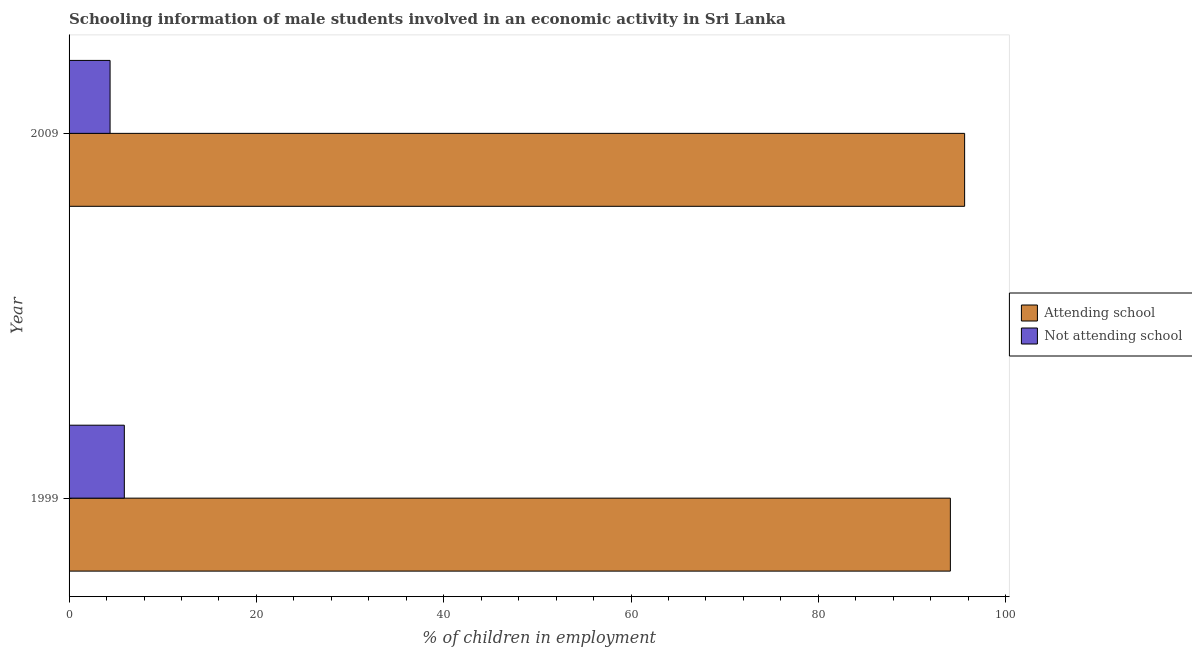How many different coloured bars are there?
Your response must be concise. 2. Are the number of bars on each tick of the Y-axis equal?
Offer a very short reply. Yes. How many bars are there on the 2nd tick from the top?
Offer a terse response. 2. How many bars are there on the 2nd tick from the bottom?
Your response must be concise. 2. What is the label of the 1st group of bars from the top?
Give a very brief answer. 2009. In how many cases, is the number of bars for a given year not equal to the number of legend labels?
Make the answer very short. 0. What is the percentage of employed males who are not attending school in 1999?
Offer a terse response. 5.9. Across all years, what is the maximum percentage of employed males who are attending school?
Offer a very short reply. 95.62. Across all years, what is the minimum percentage of employed males who are not attending school?
Keep it short and to the point. 4.38. In which year was the percentage of employed males who are not attending school maximum?
Your answer should be compact. 1999. In which year was the percentage of employed males who are attending school minimum?
Ensure brevity in your answer.  1999. What is the total percentage of employed males who are not attending school in the graph?
Your response must be concise. 10.28. What is the difference between the percentage of employed males who are attending school in 1999 and that in 2009?
Provide a short and direct response. -1.52. What is the difference between the percentage of employed males who are not attending school in 2009 and the percentage of employed males who are attending school in 1999?
Your response must be concise. -89.72. What is the average percentage of employed males who are not attending school per year?
Offer a terse response. 5.14. In the year 1999, what is the difference between the percentage of employed males who are not attending school and percentage of employed males who are attending school?
Your answer should be compact. -88.2. What is the ratio of the percentage of employed males who are not attending school in 1999 to that in 2009?
Make the answer very short. 1.35. Is the percentage of employed males who are attending school in 1999 less than that in 2009?
Make the answer very short. Yes. In how many years, is the percentage of employed males who are not attending school greater than the average percentage of employed males who are not attending school taken over all years?
Your answer should be compact. 1. What does the 1st bar from the top in 2009 represents?
Provide a succinct answer. Not attending school. What does the 2nd bar from the bottom in 2009 represents?
Provide a short and direct response. Not attending school. Are all the bars in the graph horizontal?
Give a very brief answer. Yes. What is the difference between two consecutive major ticks on the X-axis?
Ensure brevity in your answer.  20. How many legend labels are there?
Offer a very short reply. 2. How are the legend labels stacked?
Provide a succinct answer. Vertical. What is the title of the graph?
Make the answer very short. Schooling information of male students involved in an economic activity in Sri Lanka. What is the label or title of the X-axis?
Keep it short and to the point. % of children in employment. What is the % of children in employment of Attending school in 1999?
Offer a terse response. 94.1. What is the % of children in employment of Attending school in 2009?
Give a very brief answer. 95.62. What is the % of children in employment in Not attending school in 2009?
Provide a succinct answer. 4.38. Across all years, what is the maximum % of children in employment in Attending school?
Ensure brevity in your answer.  95.62. Across all years, what is the maximum % of children in employment of Not attending school?
Make the answer very short. 5.9. Across all years, what is the minimum % of children in employment in Attending school?
Offer a very short reply. 94.1. Across all years, what is the minimum % of children in employment in Not attending school?
Keep it short and to the point. 4.38. What is the total % of children in employment in Attending school in the graph?
Your answer should be very brief. 189.72. What is the total % of children in employment of Not attending school in the graph?
Give a very brief answer. 10.28. What is the difference between the % of children in employment in Attending school in 1999 and that in 2009?
Provide a short and direct response. -1.52. What is the difference between the % of children in employment in Not attending school in 1999 and that in 2009?
Keep it short and to the point. 1.52. What is the difference between the % of children in employment in Attending school in 1999 and the % of children in employment in Not attending school in 2009?
Offer a very short reply. 89.72. What is the average % of children in employment in Attending school per year?
Offer a very short reply. 94.86. What is the average % of children in employment in Not attending school per year?
Your answer should be compact. 5.14. In the year 1999, what is the difference between the % of children in employment of Attending school and % of children in employment of Not attending school?
Provide a succinct answer. 88.2. In the year 2009, what is the difference between the % of children in employment in Attending school and % of children in employment in Not attending school?
Provide a succinct answer. 91.24. What is the ratio of the % of children in employment of Attending school in 1999 to that in 2009?
Your answer should be compact. 0.98. What is the ratio of the % of children in employment of Not attending school in 1999 to that in 2009?
Your answer should be very brief. 1.35. What is the difference between the highest and the second highest % of children in employment of Attending school?
Keep it short and to the point. 1.52. What is the difference between the highest and the second highest % of children in employment of Not attending school?
Provide a succinct answer. 1.52. What is the difference between the highest and the lowest % of children in employment of Attending school?
Offer a very short reply. 1.52. What is the difference between the highest and the lowest % of children in employment in Not attending school?
Your answer should be very brief. 1.52. 